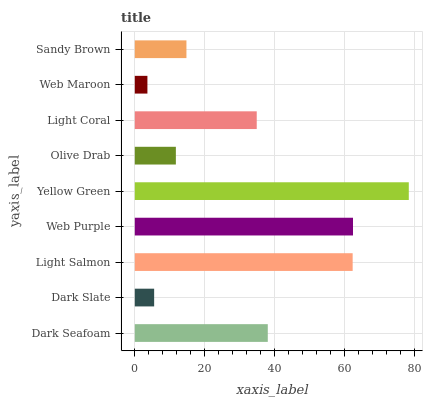Is Web Maroon the minimum?
Answer yes or no. Yes. Is Yellow Green the maximum?
Answer yes or no. Yes. Is Dark Slate the minimum?
Answer yes or no. No. Is Dark Slate the maximum?
Answer yes or no. No. Is Dark Seafoam greater than Dark Slate?
Answer yes or no. Yes. Is Dark Slate less than Dark Seafoam?
Answer yes or no. Yes. Is Dark Slate greater than Dark Seafoam?
Answer yes or no. No. Is Dark Seafoam less than Dark Slate?
Answer yes or no. No. Is Light Coral the high median?
Answer yes or no. Yes. Is Light Coral the low median?
Answer yes or no. Yes. Is Dark Slate the high median?
Answer yes or no. No. Is Dark Slate the low median?
Answer yes or no. No. 